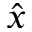Convert formula to latex. <formula><loc_0><loc_0><loc_500><loc_500>\hat { x }</formula> 